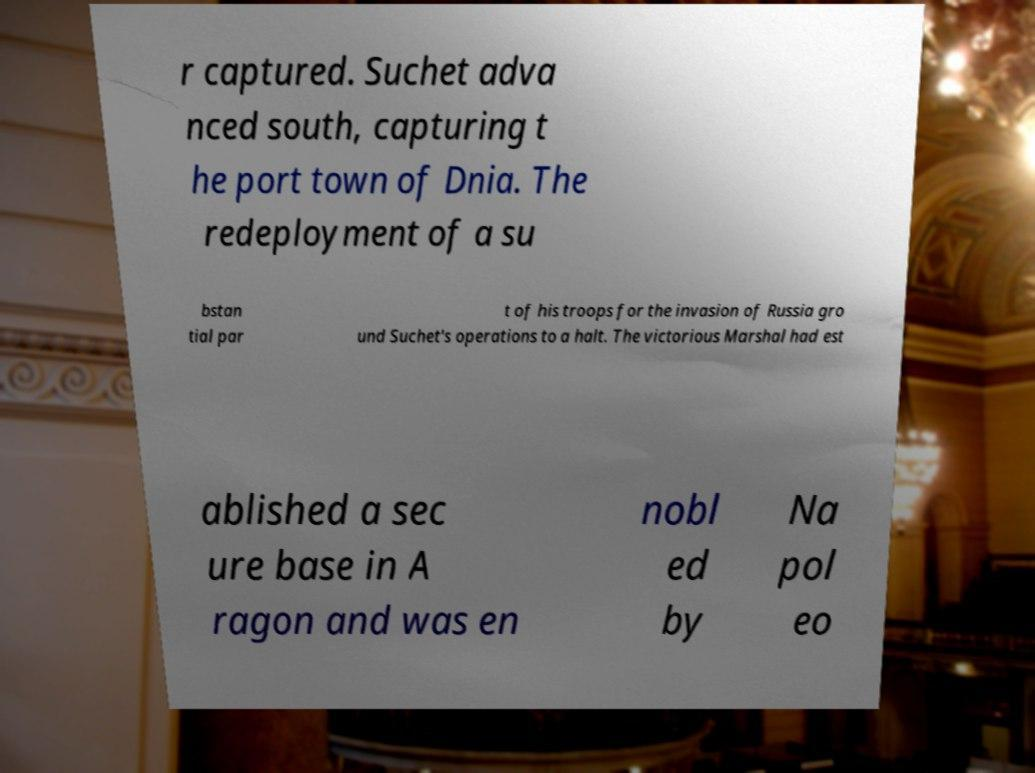Could you extract and type out the text from this image? r captured. Suchet adva nced south, capturing t he port town of Dnia. The redeployment of a su bstan tial par t of his troops for the invasion of Russia gro und Suchet's operations to a halt. The victorious Marshal had est ablished a sec ure base in A ragon and was en nobl ed by Na pol eo 